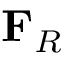Convert formula to latex. <formula><loc_0><loc_0><loc_500><loc_500>F _ { R }</formula> 